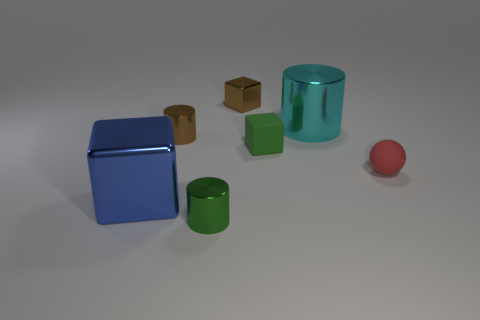What size is the green thing behind the tiny red rubber sphere?
Offer a very short reply. Small. Is the number of small metal objects less than the number of tiny things?
Give a very brief answer. Yes. Are the small block in front of the big cyan metallic thing and the tiny cube behind the big metal cylinder made of the same material?
Offer a very short reply. No. There is a tiny metallic object that is on the left side of the tiny green thing on the left side of the brown object that is behind the cyan metallic cylinder; what shape is it?
Provide a short and direct response. Cylinder. What number of tiny cubes are the same material as the ball?
Your response must be concise. 1. There is a large object that is in front of the tiny matte ball; what number of red balls are to the right of it?
Your answer should be very brief. 1. There is a metal cube behind the blue shiny object; is it the same color as the large metallic object that is left of the small green metallic object?
Provide a succinct answer. No. The metallic object that is behind the small ball and in front of the cyan cylinder has what shape?
Give a very brief answer. Cylinder. Are there any small red objects that have the same shape as the green rubber thing?
Your answer should be very brief. No. There is a green rubber object that is the same size as the green metallic thing; what shape is it?
Provide a short and direct response. Cube. 